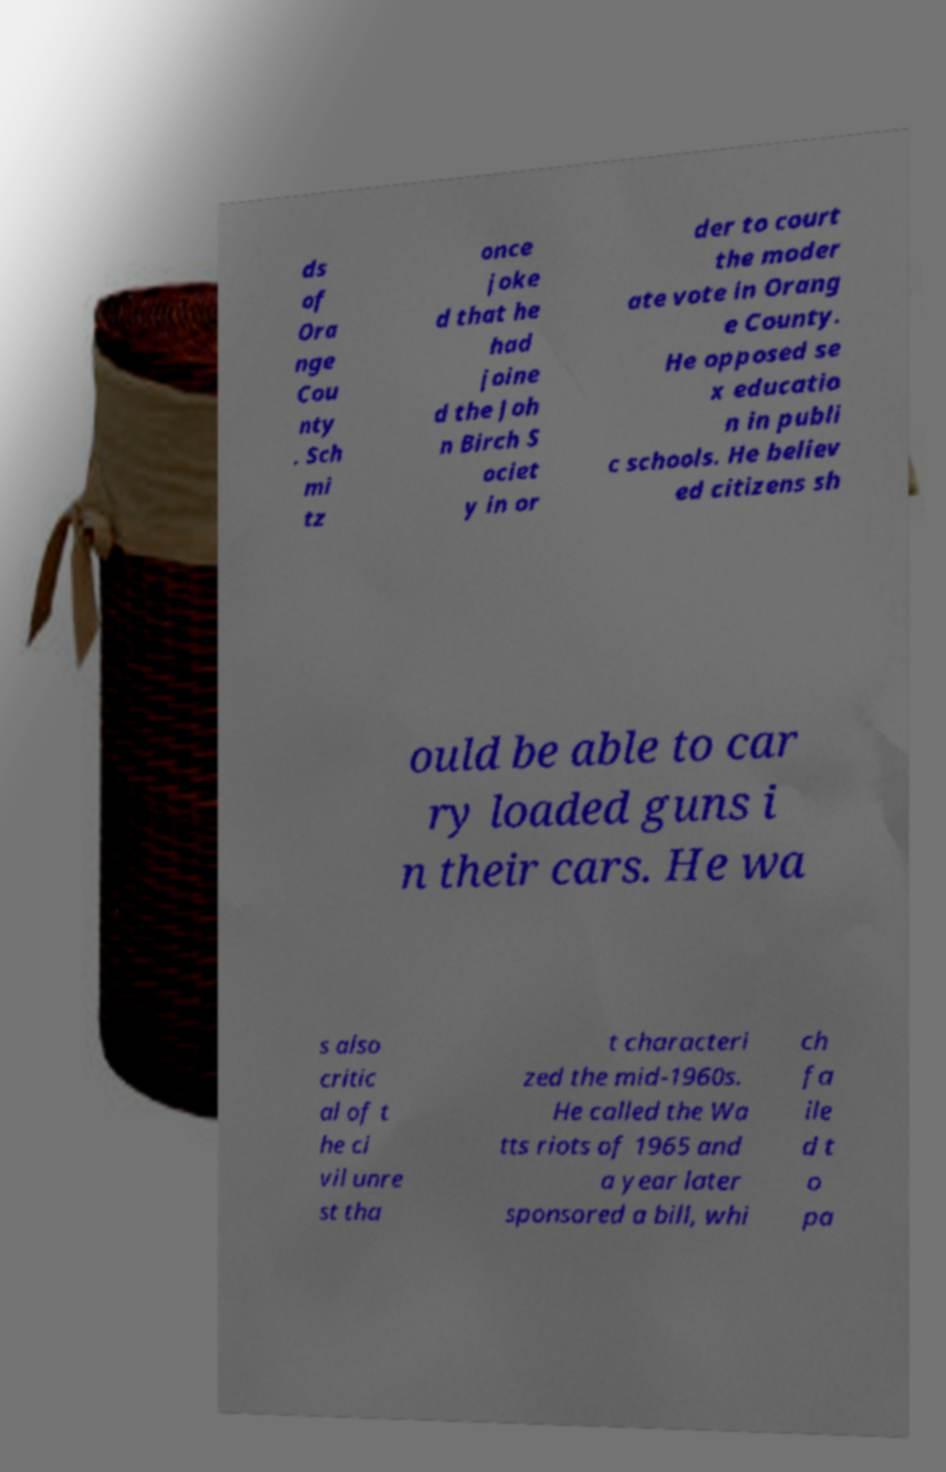I need the written content from this picture converted into text. Can you do that? ds of Ora nge Cou nty . Sch mi tz once joke d that he had joine d the Joh n Birch S ociet y in or der to court the moder ate vote in Orang e County. He opposed se x educatio n in publi c schools. He believ ed citizens sh ould be able to car ry loaded guns i n their cars. He wa s also critic al of t he ci vil unre st tha t characteri zed the mid-1960s. He called the Wa tts riots of 1965 and a year later sponsored a bill, whi ch fa ile d t o pa 